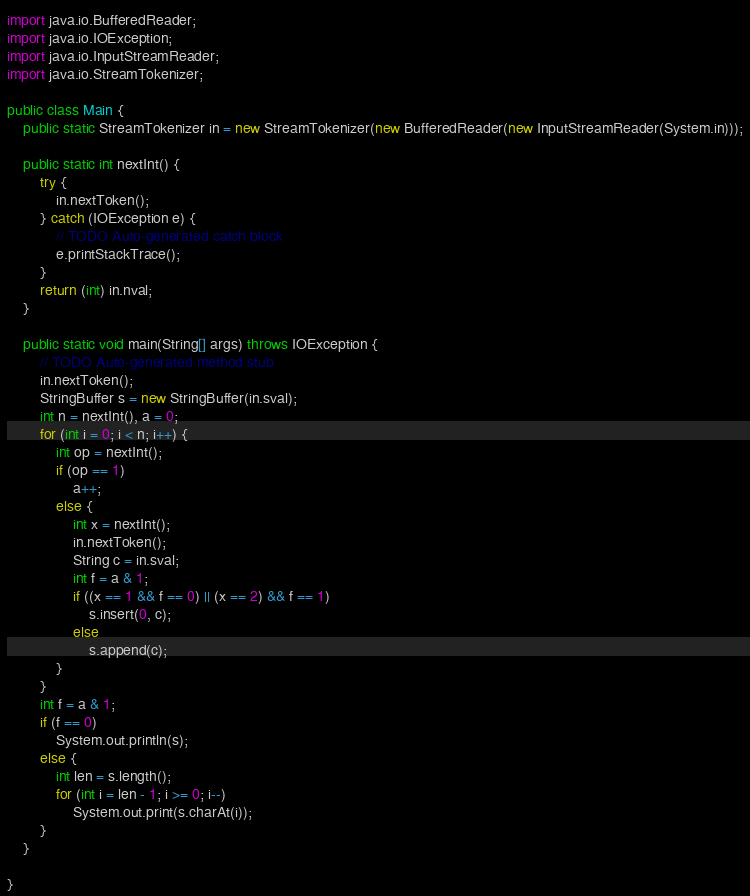Convert code to text. <code><loc_0><loc_0><loc_500><loc_500><_Java_>import java.io.BufferedReader;
import java.io.IOException;
import java.io.InputStreamReader;
import java.io.StreamTokenizer;

public class Main {
    public static StreamTokenizer in = new StreamTokenizer(new BufferedReader(new InputStreamReader(System.in)));

    public static int nextInt() {
        try {
            in.nextToken();
        } catch (IOException e) {
            // TODO Auto-generated catch block
            e.printStackTrace();
        }
        return (int) in.nval;
    }

    public static void main(String[] args) throws IOException {
        // TODO Auto-generated method stub
        in.nextToken();
        StringBuffer s = new StringBuffer(in.sval);
        int n = nextInt(), a = 0;
        for (int i = 0; i < n; i++) {
            int op = nextInt();
            if (op == 1)
                a++;
            else {
                int x = nextInt();
                in.nextToken();
                String c = in.sval;
                int f = a & 1;
                if ((x == 1 && f == 0) || (x == 2) && f == 1)
                    s.insert(0, c);
                else
                    s.append(c);
            }
        }
        int f = a & 1;
        if (f == 0)
            System.out.println(s);
        else {
            int len = s.length();
            for (int i = len - 1; i >= 0; i--)
                System.out.print(s.charAt(i));
        }
    }

}
</code> 